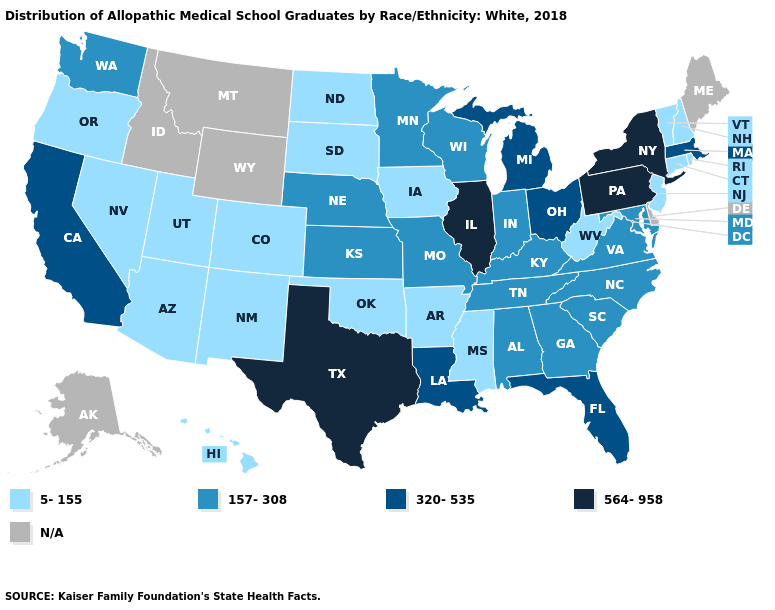Does the first symbol in the legend represent the smallest category?
Write a very short answer. Yes. What is the highest value in the South ?
Quick response, please. 564-958. What is the value of Virginia?
Quick response, please. 157-308. What is the value of Michigan?
Short answer required. 320-535. What is the value of Maine?
Answer briefly. N/A. Which states have the highest value in the USA?
Keep it brief. Illinois, New York, Pennsylvania, Texas. How many symbols are there in the legend?
Answer briefly. 5. What is the highest value in the MidWest ?
Answer briefly. 564-958. Does North Carolina have the lowest value in the USA?
Keep it brief. No. What is the highest value in states that border Washington?
Concise answer only. 5-155. What is the value of New Jersey?
Answer briefly. 5-155. Which states have the lowest value in the Northeast?
Be succinct. Connecticut, New Hampshire, New Jersey, Rhode Island, Vermont. Name the states that have a value in the range N/A?
Concise answer only. Alaska, Delaware, Idaho, Maine, Montana, Wyoming. What is the value of Maine?
Short answer required. N/A. 